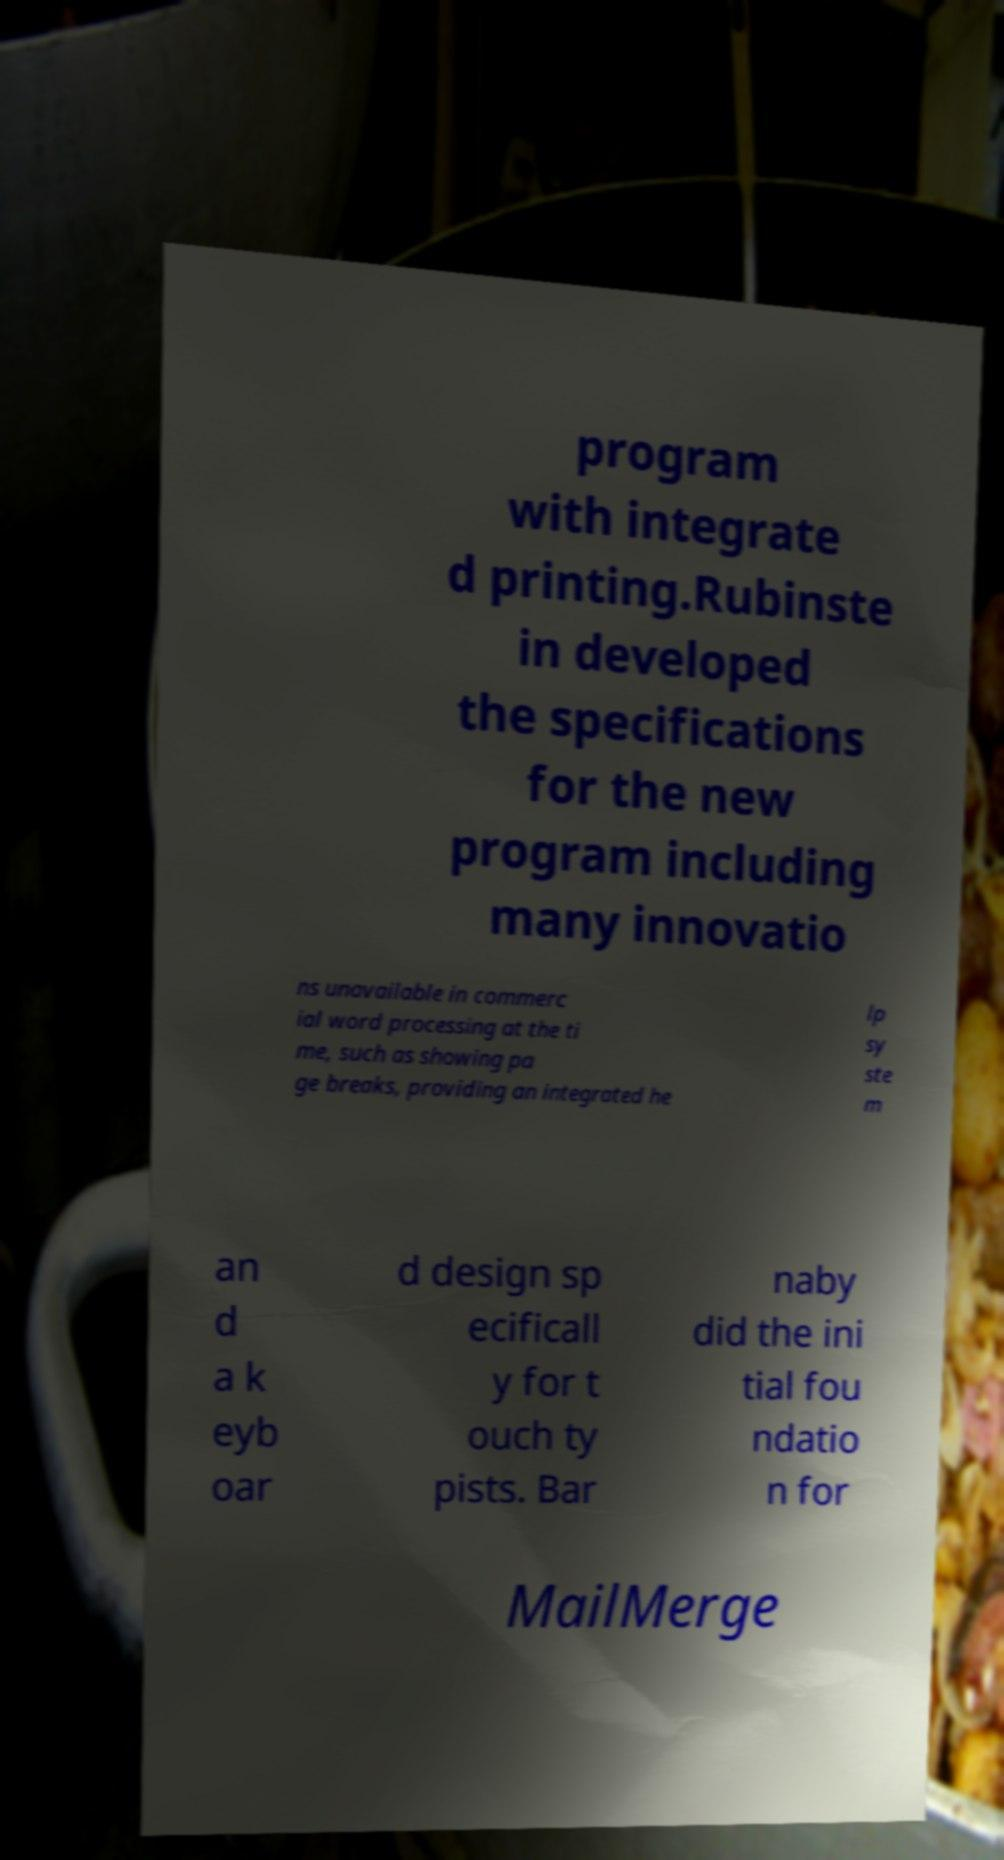I need the written content from this picture converted into text. Can you do that? program with integrate d printing.Rubinste in developed the specifications for the new program including many innovatio ns unavailable in commerc ial word processing at the ti me, such as showing pa ge breaks, providing an integrated he lp sy ste m an d a k eyb oar d design sp ecificall y for t ouch ty pists. Bar naby did the ini tial fou ndatio n for MailMerge 